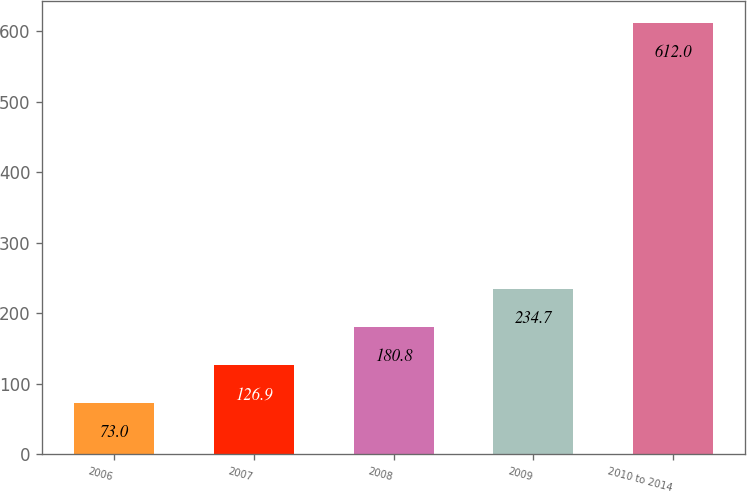Convert chart. <chart><loc_0><loc_0><loc_500><loc_500><bar_chart><fcel>2006<fcel>2007<fcel>2008<fcel>2009<fcel>2010 to 2014<nl><fcel>73<fcel>126.9<fcel>180.8<fcel>234.7<fcel>612<nl></chart> 